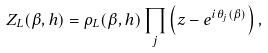Convert formula to latex. <formula><loc_0><loc_0><loc_500><loc_500>Z _ { L } ( \beta , h ) = \rho _ { L } ( \beta , h ) \prod _ { j } { \left ( z - e ^ { i \theta _ { j } ( \beta ) } \right ) } \, ,</formula> 